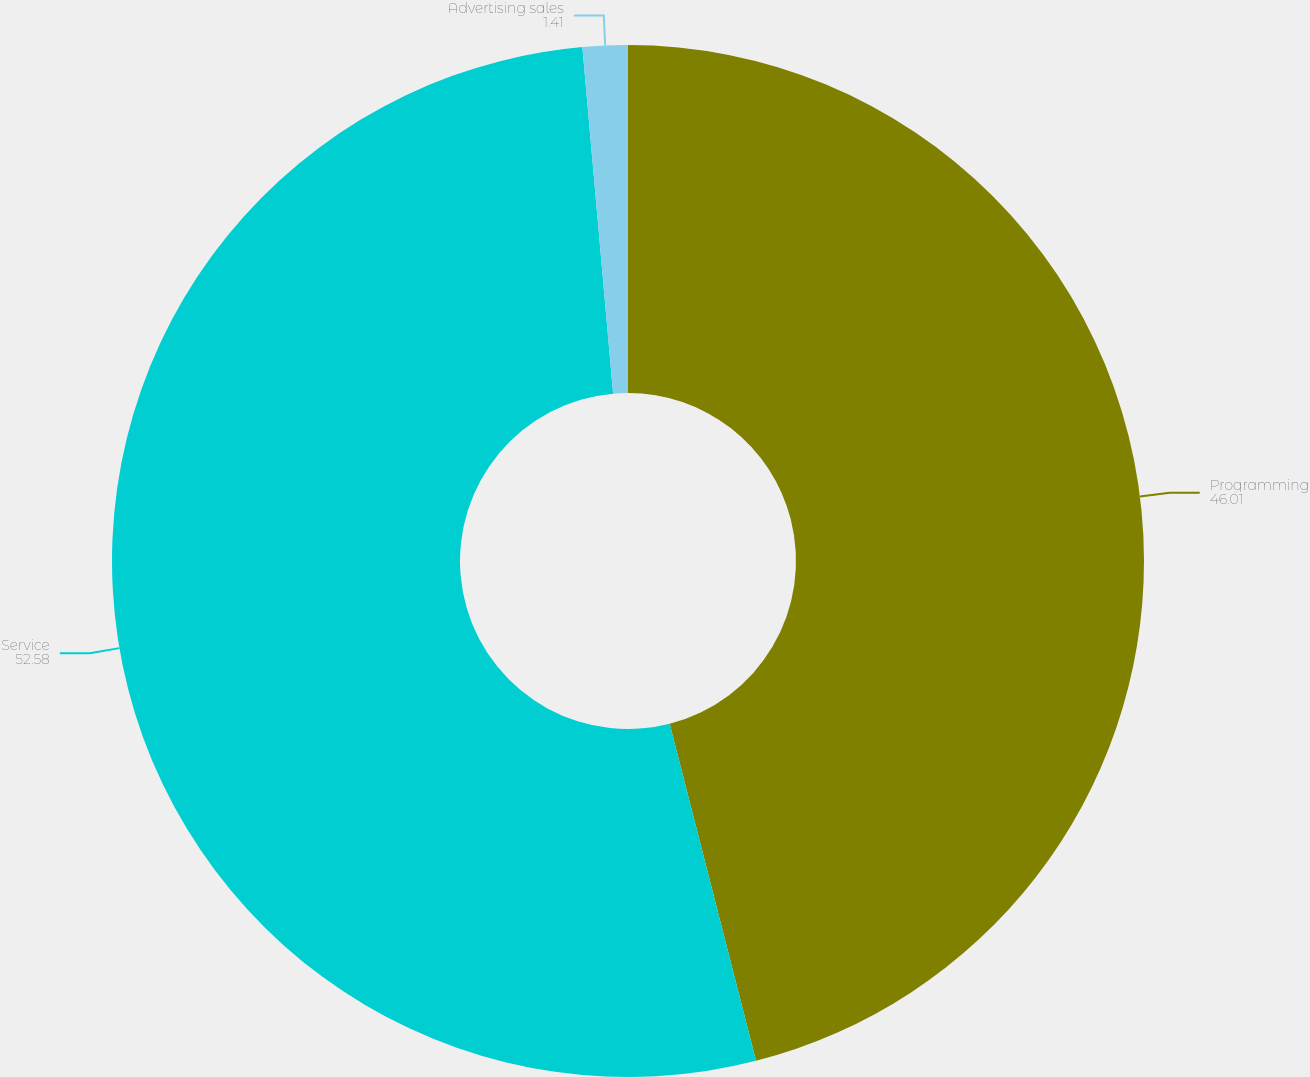Convert chart. <chart><loc_0><loc_0><loc_500><loc_500><pie_chart><fcel>Programming<fcel>Service<fcel>Advertising sales<nl><fcel>46.01%<fcel>52.58%<fcel>1.41%<nl></chart> 